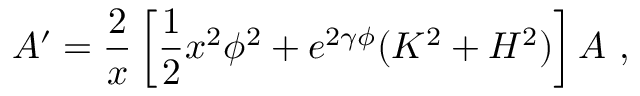Convert formula to latex. <formula><loc_0><loc_0><loc_500><loc_500>A ^ { \prime } = \frac { 2 } { x } \left [ \frac { 1 } { 2 } x ^ { 2 } \phi ^ { 2 } + e ^ { 2 \gamma \phi } ( K ^ { 2 } + H ^ { 2 } ) \right ] A \ ,</formula> 